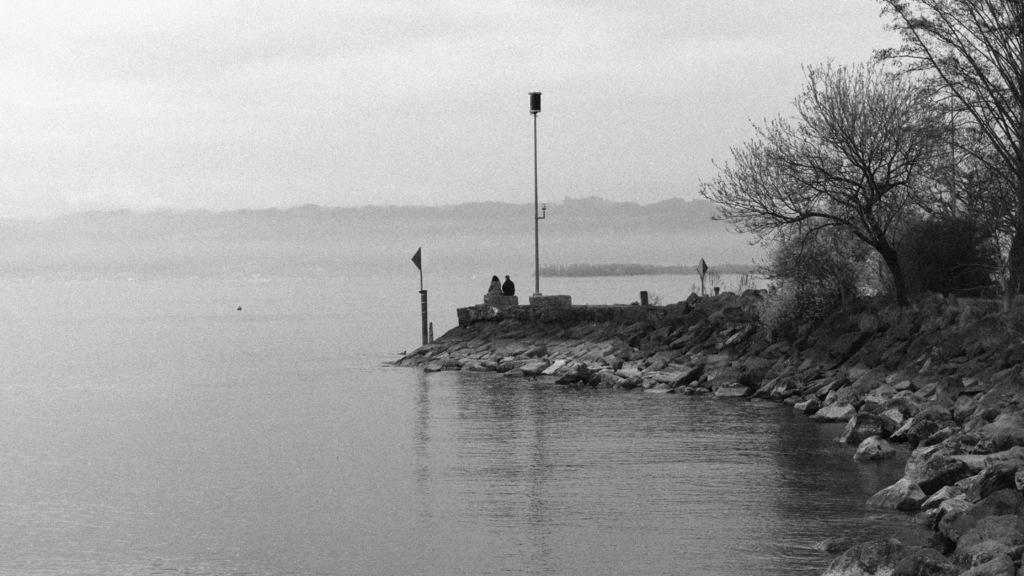What is the primary element visible in the image? There is water in the image. What other natural features can be seen in the image? There are rocks, trees, and hills visible in the image. Are there any man-made structures present in the image? Yes, there are poles in the image. What are the two people in the image doing? They are sitting on a rock in the image. What is visible in the background of the image? The sky is visible in the background of the image. What type of stew is being cooked on the rocks in the image? There is no stew being cooked in the image; it features water, rocks, trees, poles, and two people sitting on a rock. What kind of fuel is being used to power the bear in the image? There is no bear present in the image, and therefore no fuel is being used to power it. 